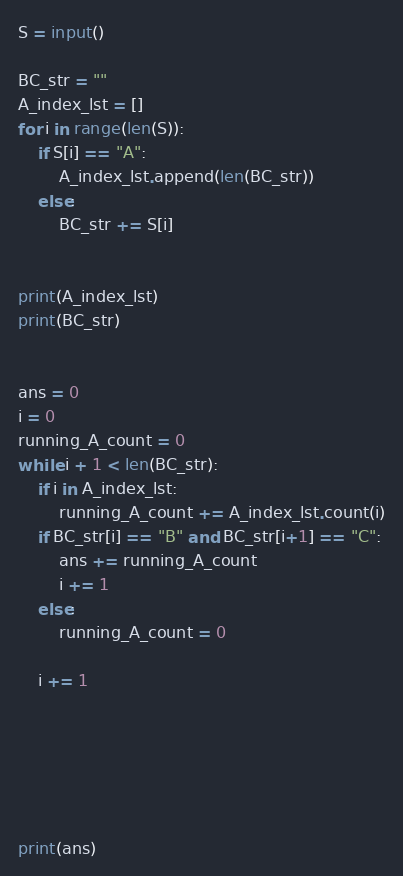<code> <loc_0><loc_0><loc_500><loc_500><_Python_>S = input()

BC_str = ""
A_index_lst = []
for i in range(len(S)):
    if S[i] == "A":
        A_index_lst.append(len(BC_str))
    else:
        BC_str += S[i]


print(A_index_lst)
print(BC_str)


ans = 0
i = 0
running_A_count = 0
while i + 1 < len(BC_str):
    if i in A_index_lst:
        running_A_count += A_index_lst.count(i)
    if BC_str[i] == "B" and BC_str[i+1] == "C":
        ans += running_A_count
        i += 1
    else:
        running_A_count = 0
    
    i += 1






print(ans)</code> 